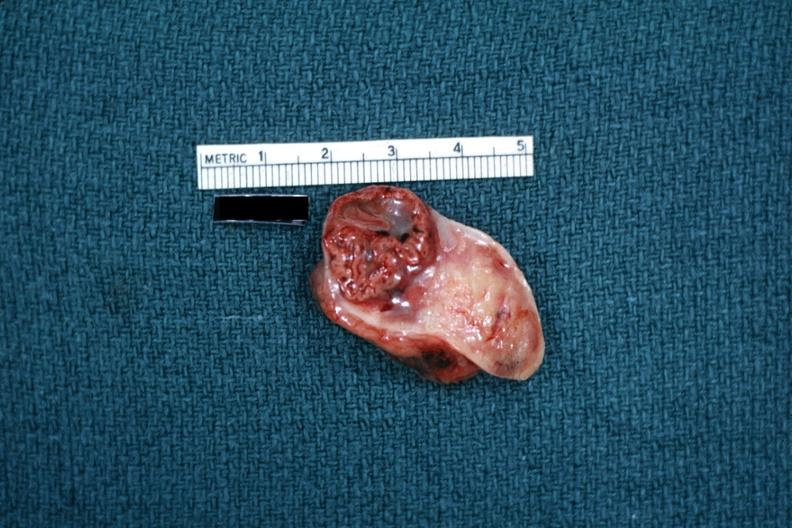what is present?
Answer the question using a single word or phrase. Corpus luteum 